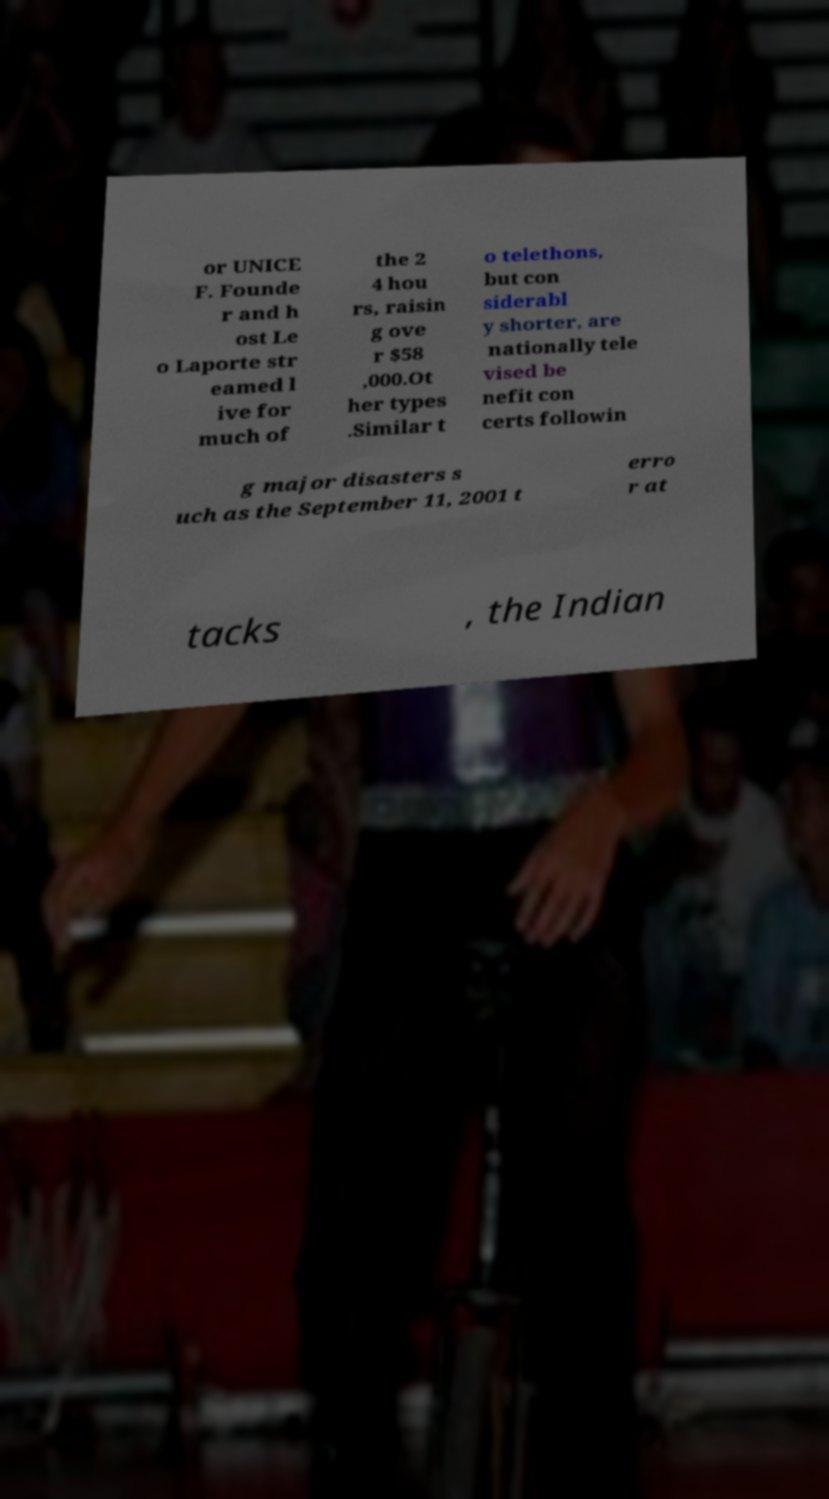Please identify and transcribe the text found in this image. or UNICE F. Founde r and h ost Le o Laporte str eamed l ive for much of the 2 4 hou rs, raisin g ove r $58 ,000.Ot her types .Similar t o telethons, but con siderabl y shorter, are nationally tele vised be nefit con certs followin g major disasters s uch as the September 11, 2001 t erro r at tacks , the Indian 